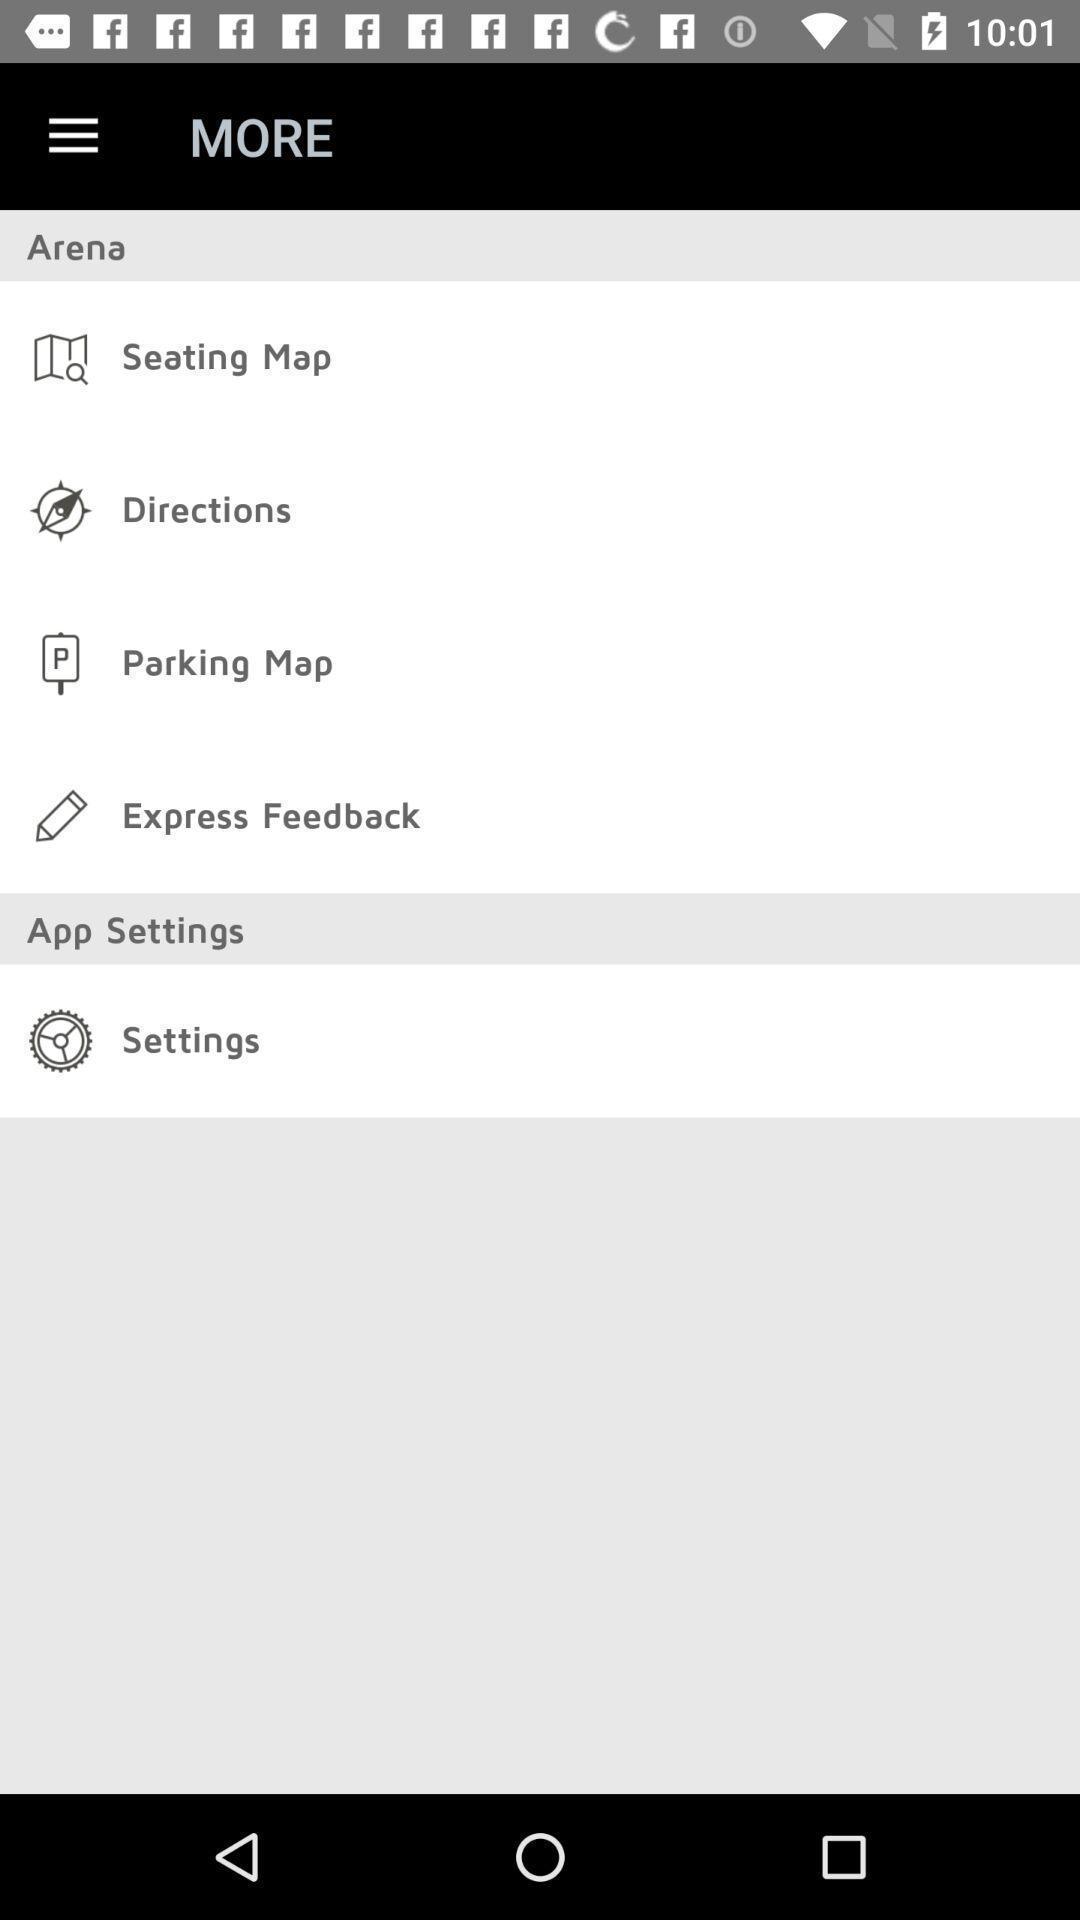Explain what's happening in this screen capture. Page displaying menu with settings for an application. 